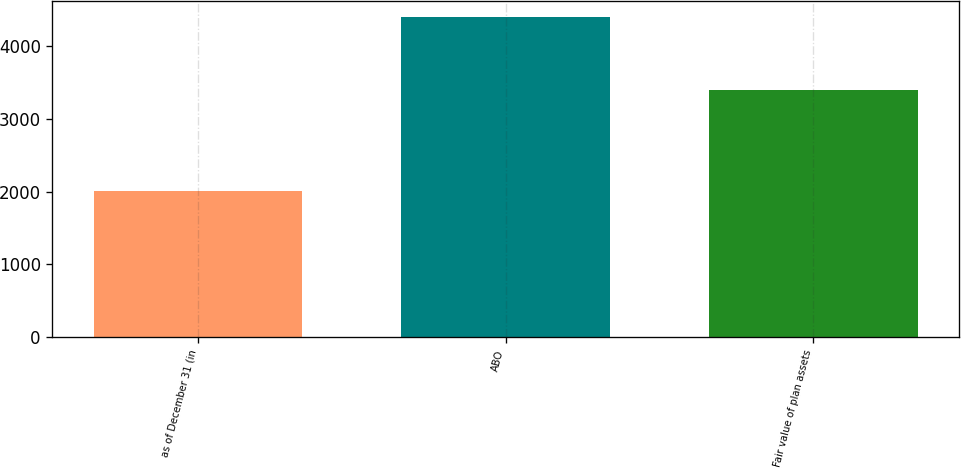Convert chart. <chart><loc_0><loc_0><loc_500><loc_500><bar_chart><fcel>as of December 31 (in<fcel>ABO<fcel>Fair value of plan assets<nl><fcel>2011<fcel>4392<fcel>3393<nl></chart> 